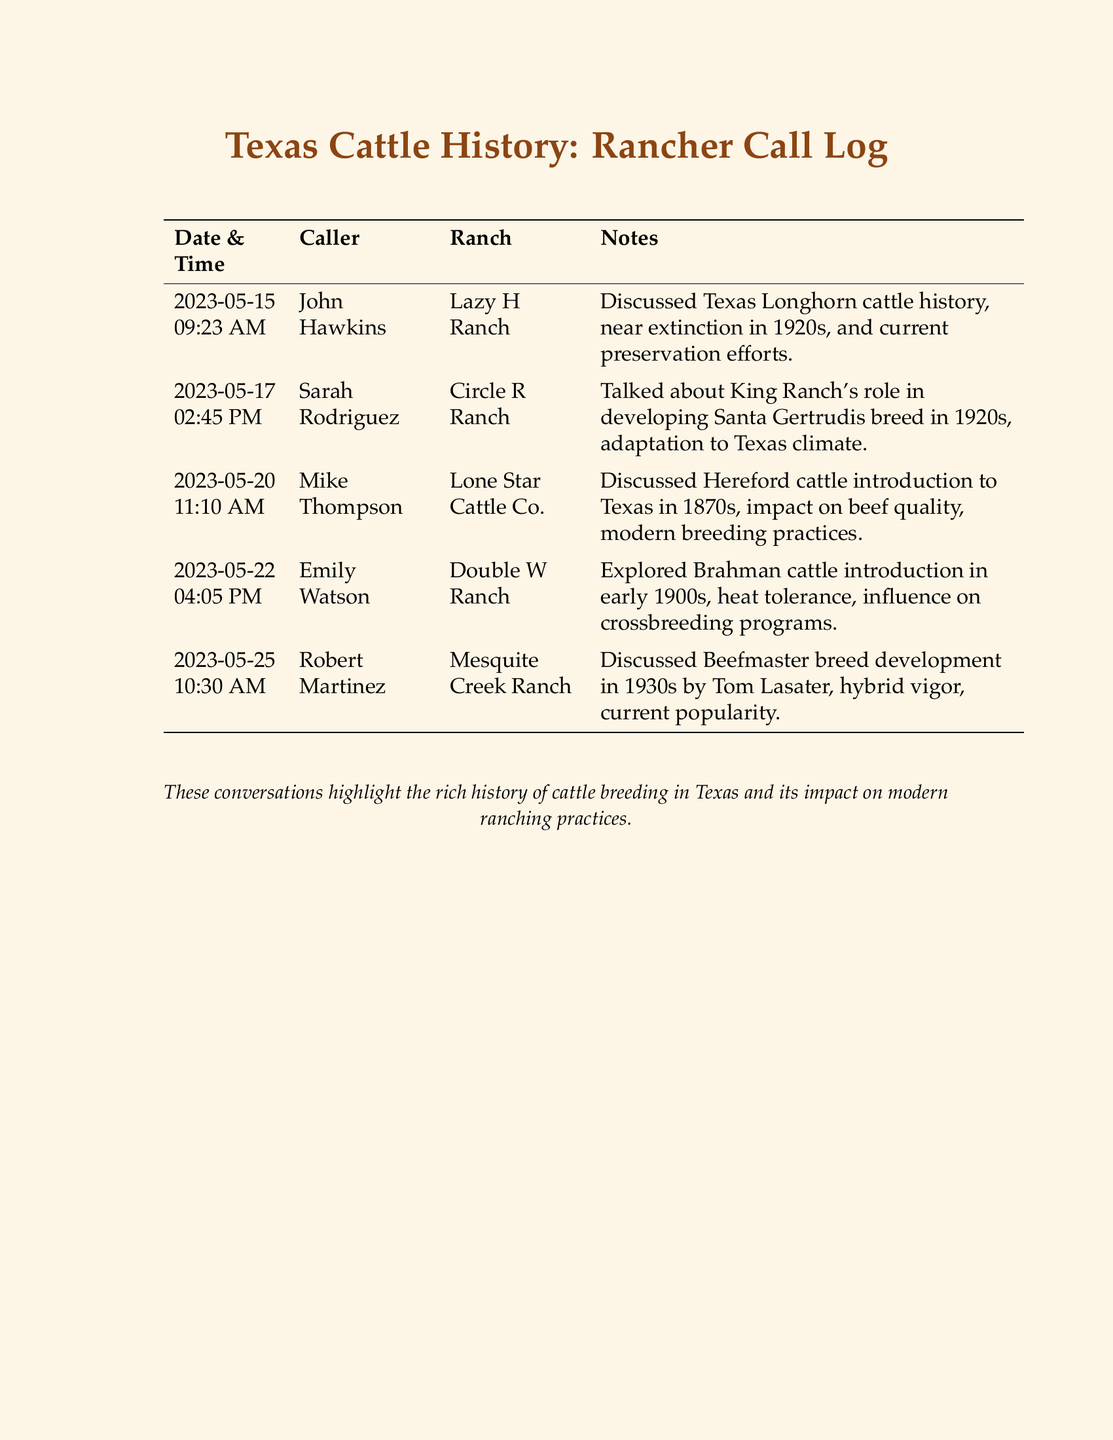What is the date of the first call? The first call in the log is dated May 15, 2023.
Answer: May 15, 2023 Who called the Lazy H Ranch? The caller listed for the Lazy H Ranch is John Hawkins.
Answer: John Hawkins What breed's history was discussed during the call with Sarah Rodriguez? The call with Sarah Rodriguez focused on the Santa Gertrudis breed.
Answer: Santa Gertrudis Which ranch was Mike Thompson associated with? Mike Thompson was associated with Lone Star Cattle Co.
Answer: Lone Star Cattle Co What historical aspect did Robert Martinez discuss? Robert Martinez discussed Beefmaster breed development in the 1930s.
Answer: Beefmaster breed development in the 1930s How many calls were made in total? There are five calls logged in the document.
Answer: 5 What are the ranching strategies mentioned in Emily Watson's call? The call with Emily Watson explored Brahman cattle influence on crossbreeding programs.
Answer: Crossbreeding programs In what year was the Hereford cattle introduced to Texas? Hereford cattle were introduced to Texas in the 1870s.
Answer: 1870s What was a major influence on the development of Santa Gertrudis? King Ranch played a significant role in developing the Santa Gertrudis breed.
Answer: King Ranch 